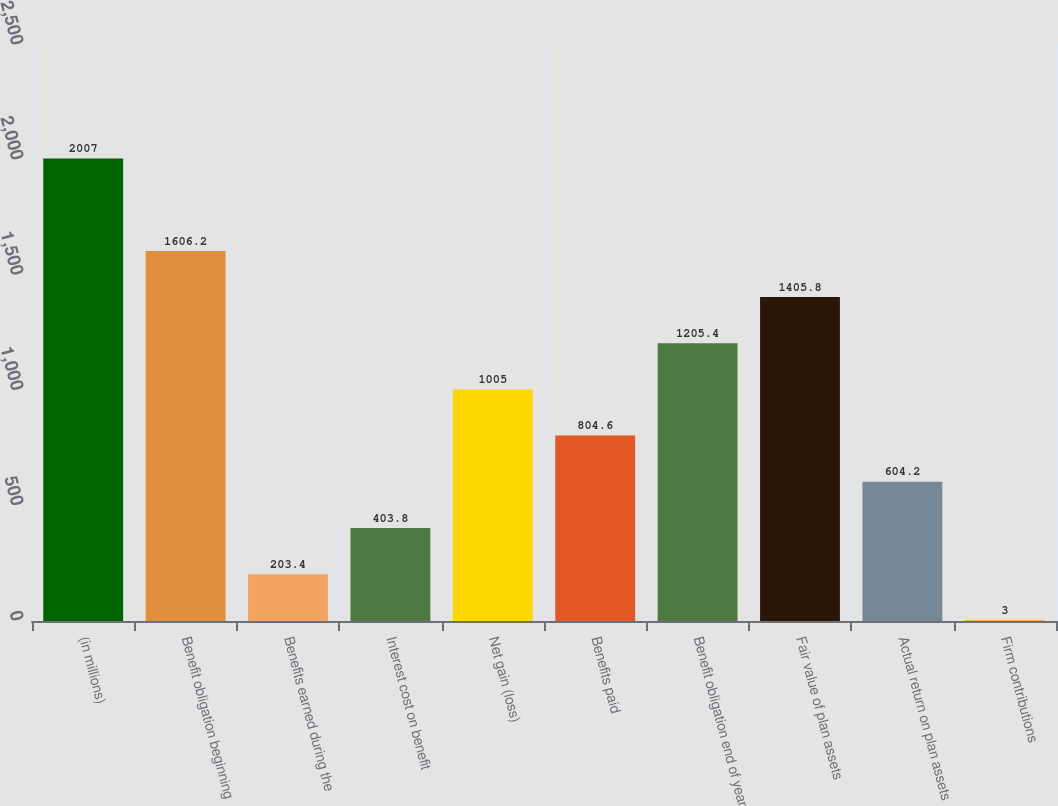<chart> <loc_0><loc_0><loc_500><loc_500><bar_chart><fcel>(in millions)<fcel>Benefit obligation beginning<fcel>Benefits earned during the<fcel>Interest cost on benefit<fcel>Net gain (loss)<fcel>Benefits paid<fcel>Benefit obligation end of year<fcel>Fair value of plan assets<fcel>Actual return on plan assets<fcel>Firm contributions<nl><fcel>2007<fcel>1606.2<fcel>203.4<fcel>403.8<fcel>1005<fcel>804.6<fcel>1205.4<fcel>1405.8<fcel>604.2<fcel>3<nl></chart> 